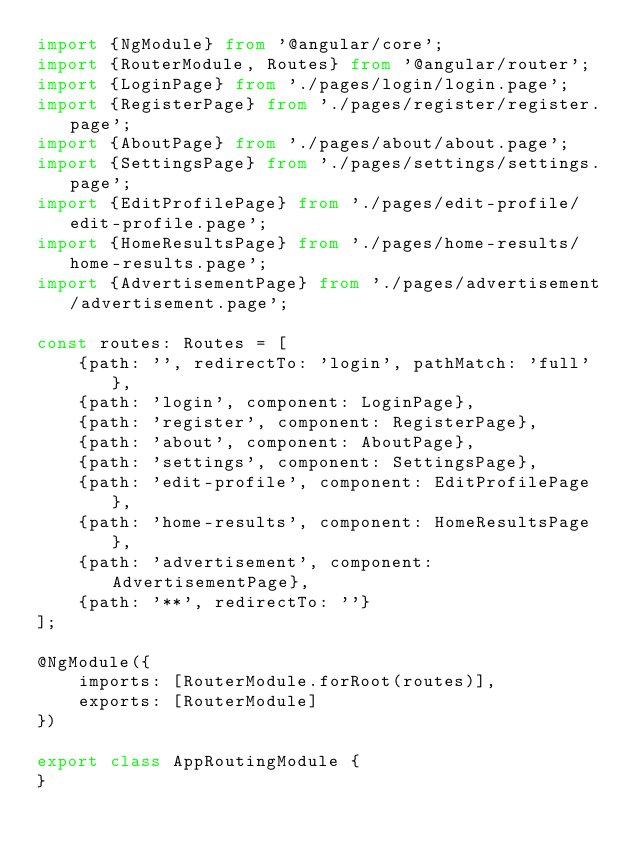<code> <loc_0><loc_0><loc_500><loc_500><_TypeScript_>import {NgModule} from '@angular/core';
import {RouterModule, Routes} from '@angular/router';
import {LoginPage} from './pages/login/login.page';
import {RegisterPage} from './pages/register/register.page';
import {AboutPage} from './pages/about/about.page';
import {SettingsPage} from './pages/settings/settings.page';
import {EditProfilePage} from './pages/edit-profile/edit-profile.page';
import {HomeResultsPage} from './pages/home-results/home-results.page';
import {AdvertisementPage} from './pages/advertisement/advertisement.page';

const routes: Routes = [
    {path: '', redirectTo: 'login', pathMatch: 'full'},
    {path: 'login', component: LoginPage},
    {path: 'register', component: RegisterPage},
    {path: 'about', component: AboutPage},
    {path: 'settings', component: SettingsPage},
    {path: 'edit-profile', component: EditProfilePage},
    {path: 'home-results', component: HomeResultsPage},
    {path: 'advertisement', component: AdvertisementPage},
    {path: '**', redirectTo: ''}
];

@NgModule({
    imports: [RouterModule.forRoot(routes)],
    exports: [RouterModule]
})

export class AppRoutingModule {
}
</code> 